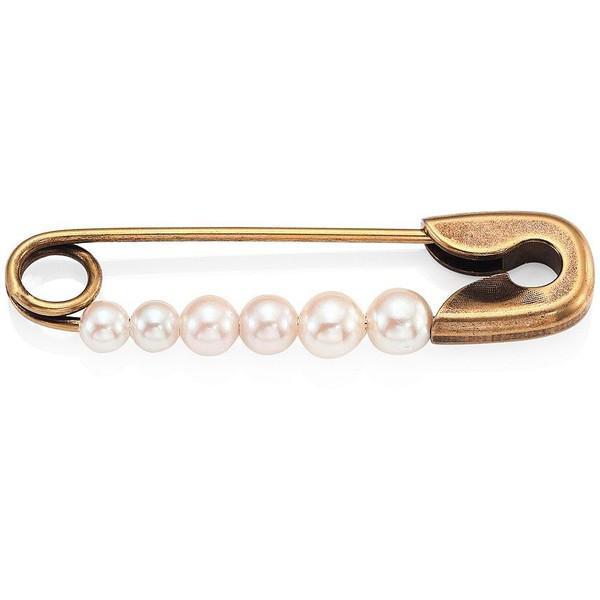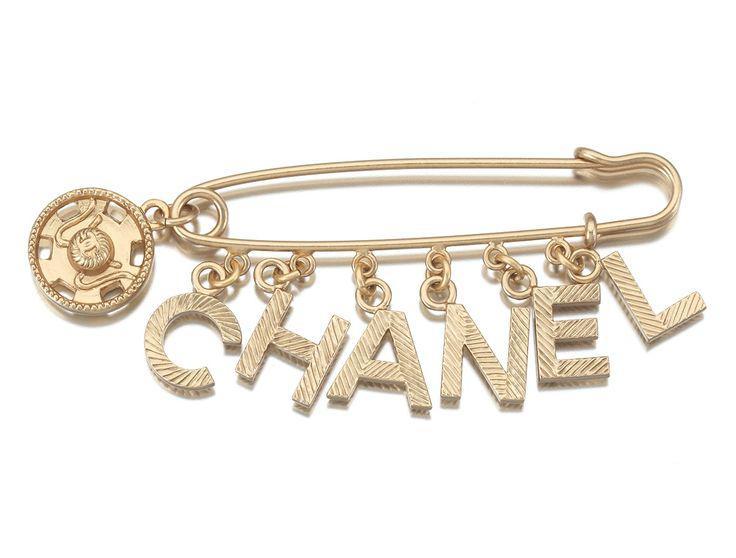The first image is the image on the left, the second image is the image on the right. Examine the images to the left and right. Is the description "The pin on the left is strung with six beads, and the pin on the right features gold letter shapes." accurate? Answer yes or no. Yes. The first image is the image on the left, the second image is the image on the right. Examine the images to the left and right. Is the description "there is a pin with at least one charm being a key" accurate? Answer yes or no. No. The first image is the image on the left, the second image is the image on the right. Evaluate the accuracy of this statement regarding the images: "There is a heart charm to the right of some other charms.". Is it true? Answer yes or no. No. The first image is the image on the left, the second image is the image on the right. Considering the images on both sides, is "A gold safety pin is strung with a row of six black beads and suspends a tassel made of chains." valid? Answer yes or no. No. 